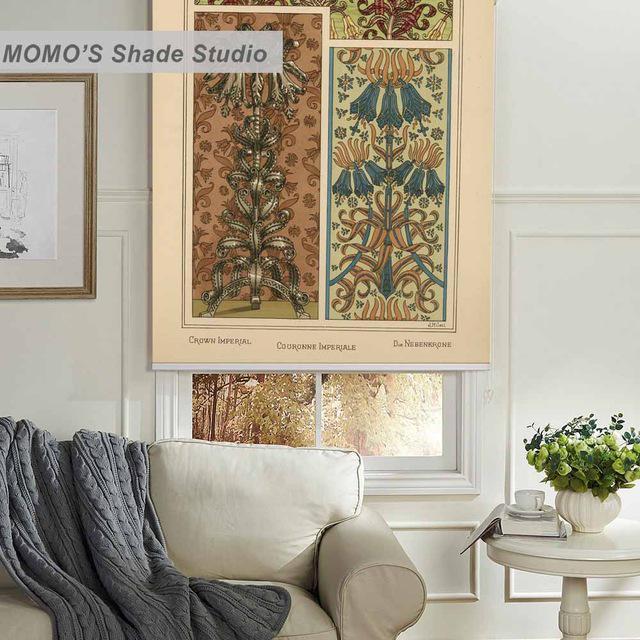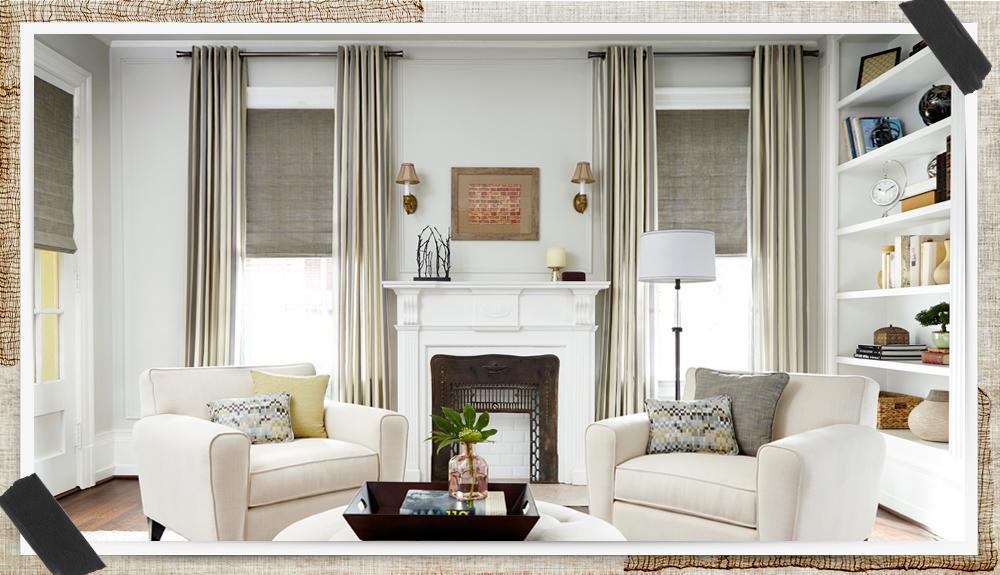The first image is the image on the left, the second image is the image on the right. Analyze the images presented: Is the assertion "An image shows a chandelier over a table and chairs in front of a corner with a total of three tall windows hung with solid-colored drapes in front of shades pulled half-way down." valid? Answer yes or no. No. 